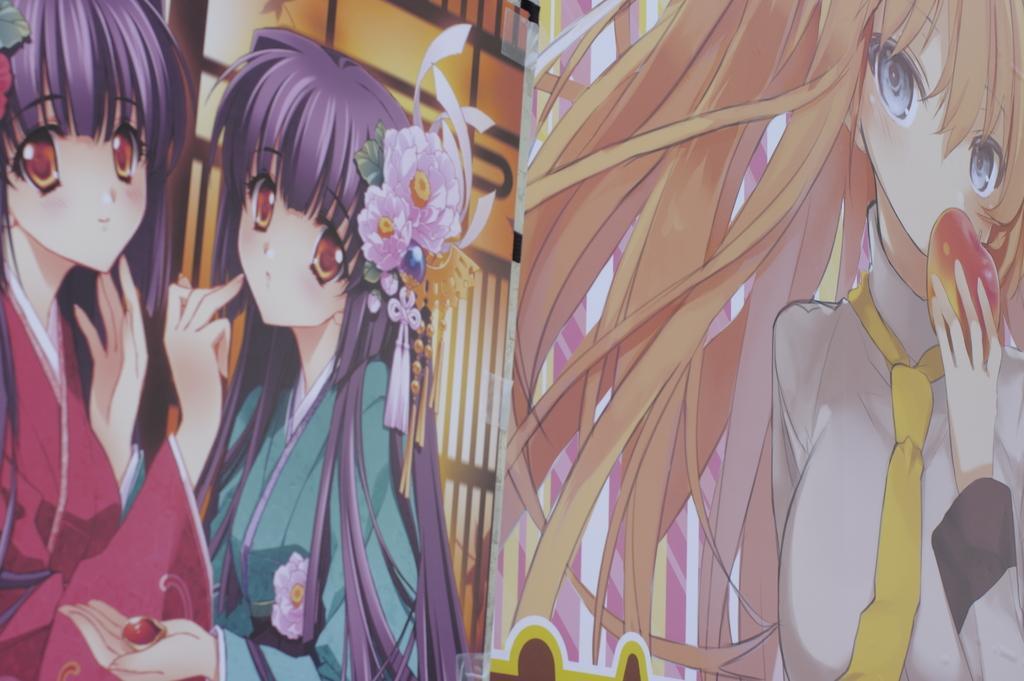Can you describe this image briefly? In this image I can see the animation picture of three women who are wearing pink, green and white colored dresses. I can see their hair are violet and yellow in color and I can see one of the woman is holding a fruit in her hand. 